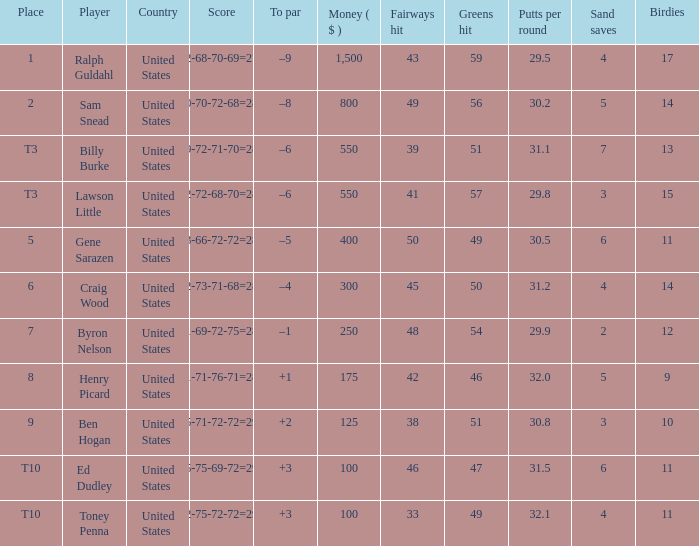Which score carries a reward of $400? 73-66-72-72=283. 